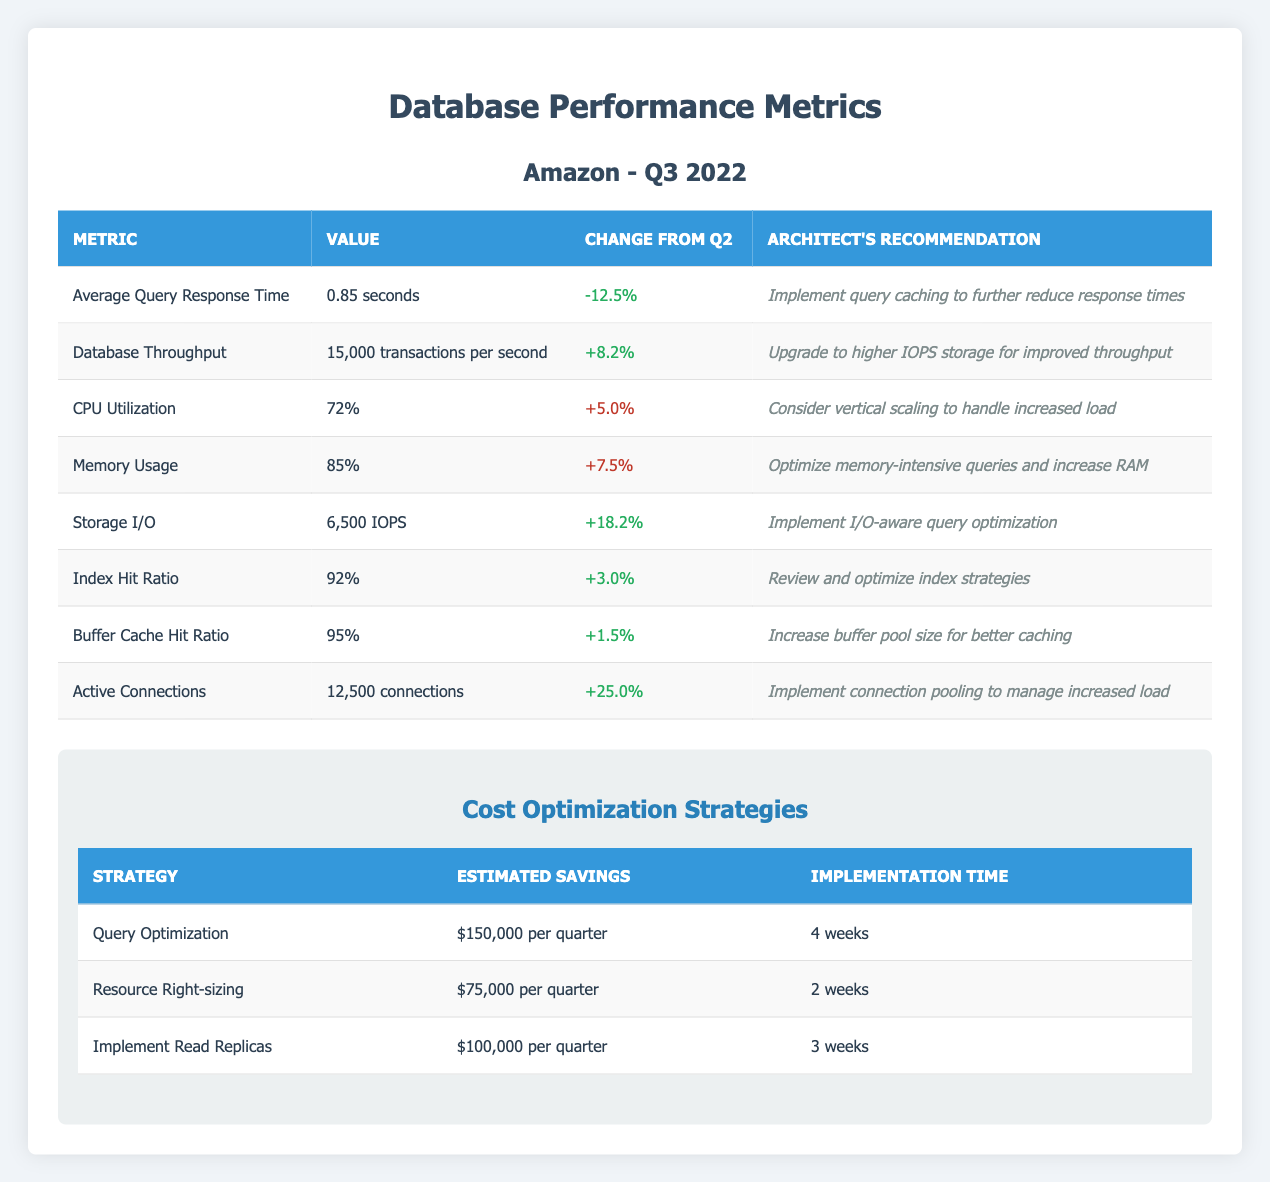What was the Average Query Response Time in Q3 2022? According to the table, the Average Query Response Time value is listed as 0.85 seconds in Q3 2022.
Answer: 0.85 seconds What is the change in CPU Utilization from the previous quarter? The table shows that the change in CPU Utilization from the previous quarter is +5.0%.
Answer: +5.0% How many transactions per second does the Database Throughput achieve? The table states that the Database Throughput is 15,000 transactions per second.
Answer: 15,000 transactions per second What is the Index Hit Ratio, and did it increase or decrease from the last quarter? The Index Hit Ratio is 92% and it increased by +3.0% from the previous quarter, as stated in the table.
Answer: 92% (increased) What is the total estimated savings when combining all cost optimization strategies? The total estimated savings can be calculated by adding $150,000 (Query Optimization), $75,000 (Resource Right-sizing), and $100,000 (Implement Read Replicas), resulting in $325,000 per quarter.
Answer: $325,000 per quarter Is the Memory Usage above 80%? The table indicates that Memory Usage is 85%, which is above 80%.
Answer: Yes How does the Buffer Cache Hit Ratio compare to the Index Hit Ratio in terms of performance? The Buffer Cache Hit Ratio is 95%, which is higher than the Index Hit Ratio of 92%, indicating better performance in caching.
Answer: Better performance at 95% What recommendation suggests a strategy for managing increased Active Connections? The recommendation for managing increased Active Connections is to implement connection pooling as stated in the recommendation column.
Answer: Implement connection pooling What specific recommendation could reduce the Average Query Response Time? The recommendation for reducing the Average Query Response Time is to implement query caching, as indicated in the table.
Answer: Implement query caching 